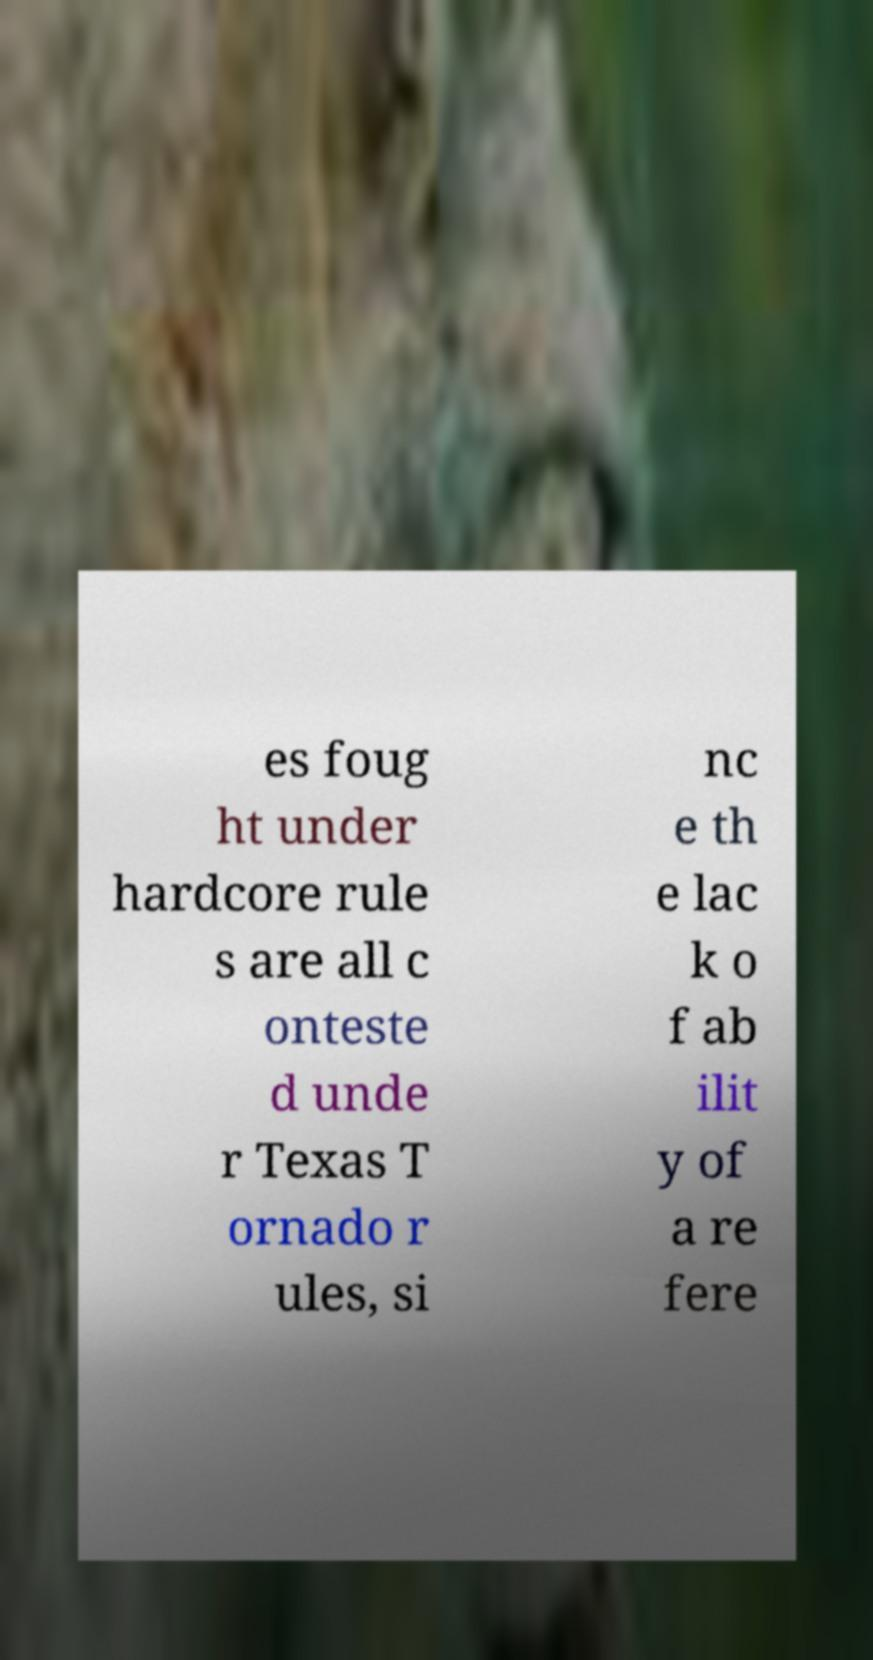Can you accurately transcribe the text from the provided image for me? es foug ht under hardcore rule s are all c onteste d unde r Texas T ornado r ules, si nc e th e lac k o f ab ilit y of a re fere 